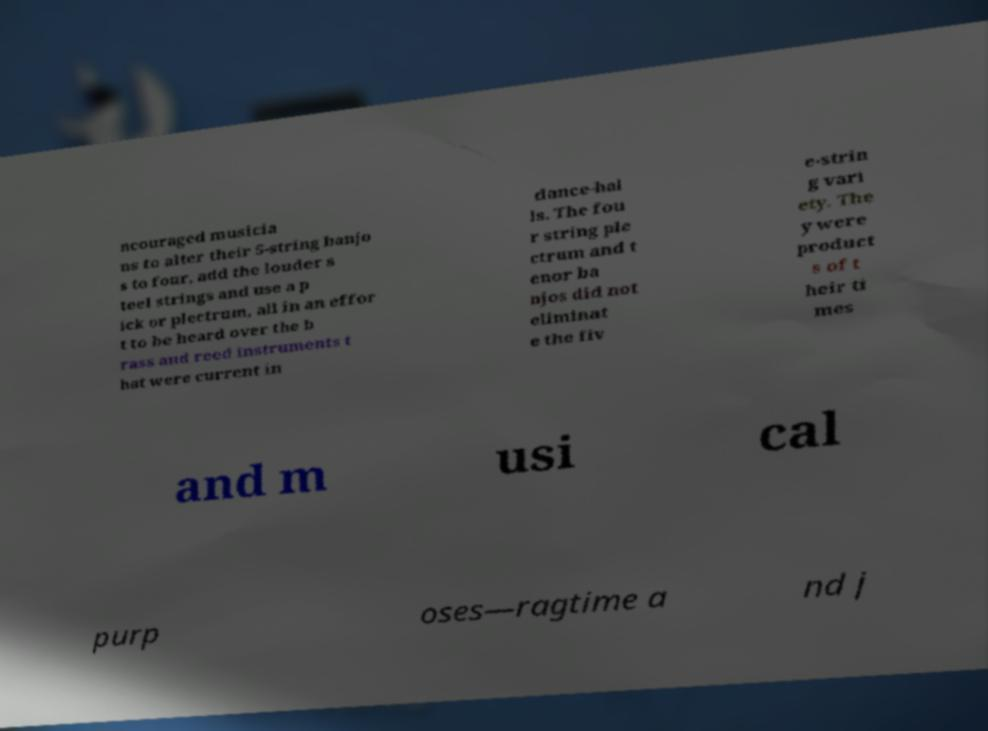For documentation purposes, I need the text within this image transcribed. Could you provide that? ncouraged musicia ns to alter their 5-string banjo s to four, add the louder s teel strings and use a p ick or plectrum, all in an effor t to be heard over the b rass and reed instruments t hat were current in dance-hal ls. The fou r string ple ctrum and t enor ba njos did not eliminat e the fiv e-strin g vari ety. The y were product s of t heir ti mes and m usi cal purp oses—ragtime a nd j 